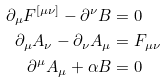<formula> <loc_0><loc_0><loc_500><loc_500>\partial _ { \mu } F ^ { \left [ \mu \nu \right ] } - \partial ^ { \nu } B & = 0 \\ \partial _ { \mu } A _ { \nu } - \partial _ { \nu } A _ { \mu } & = F _ { \mu \nu } \\ \partial ^ { \mu } A _ { \mu } + \alpha B & = 0</formula> 